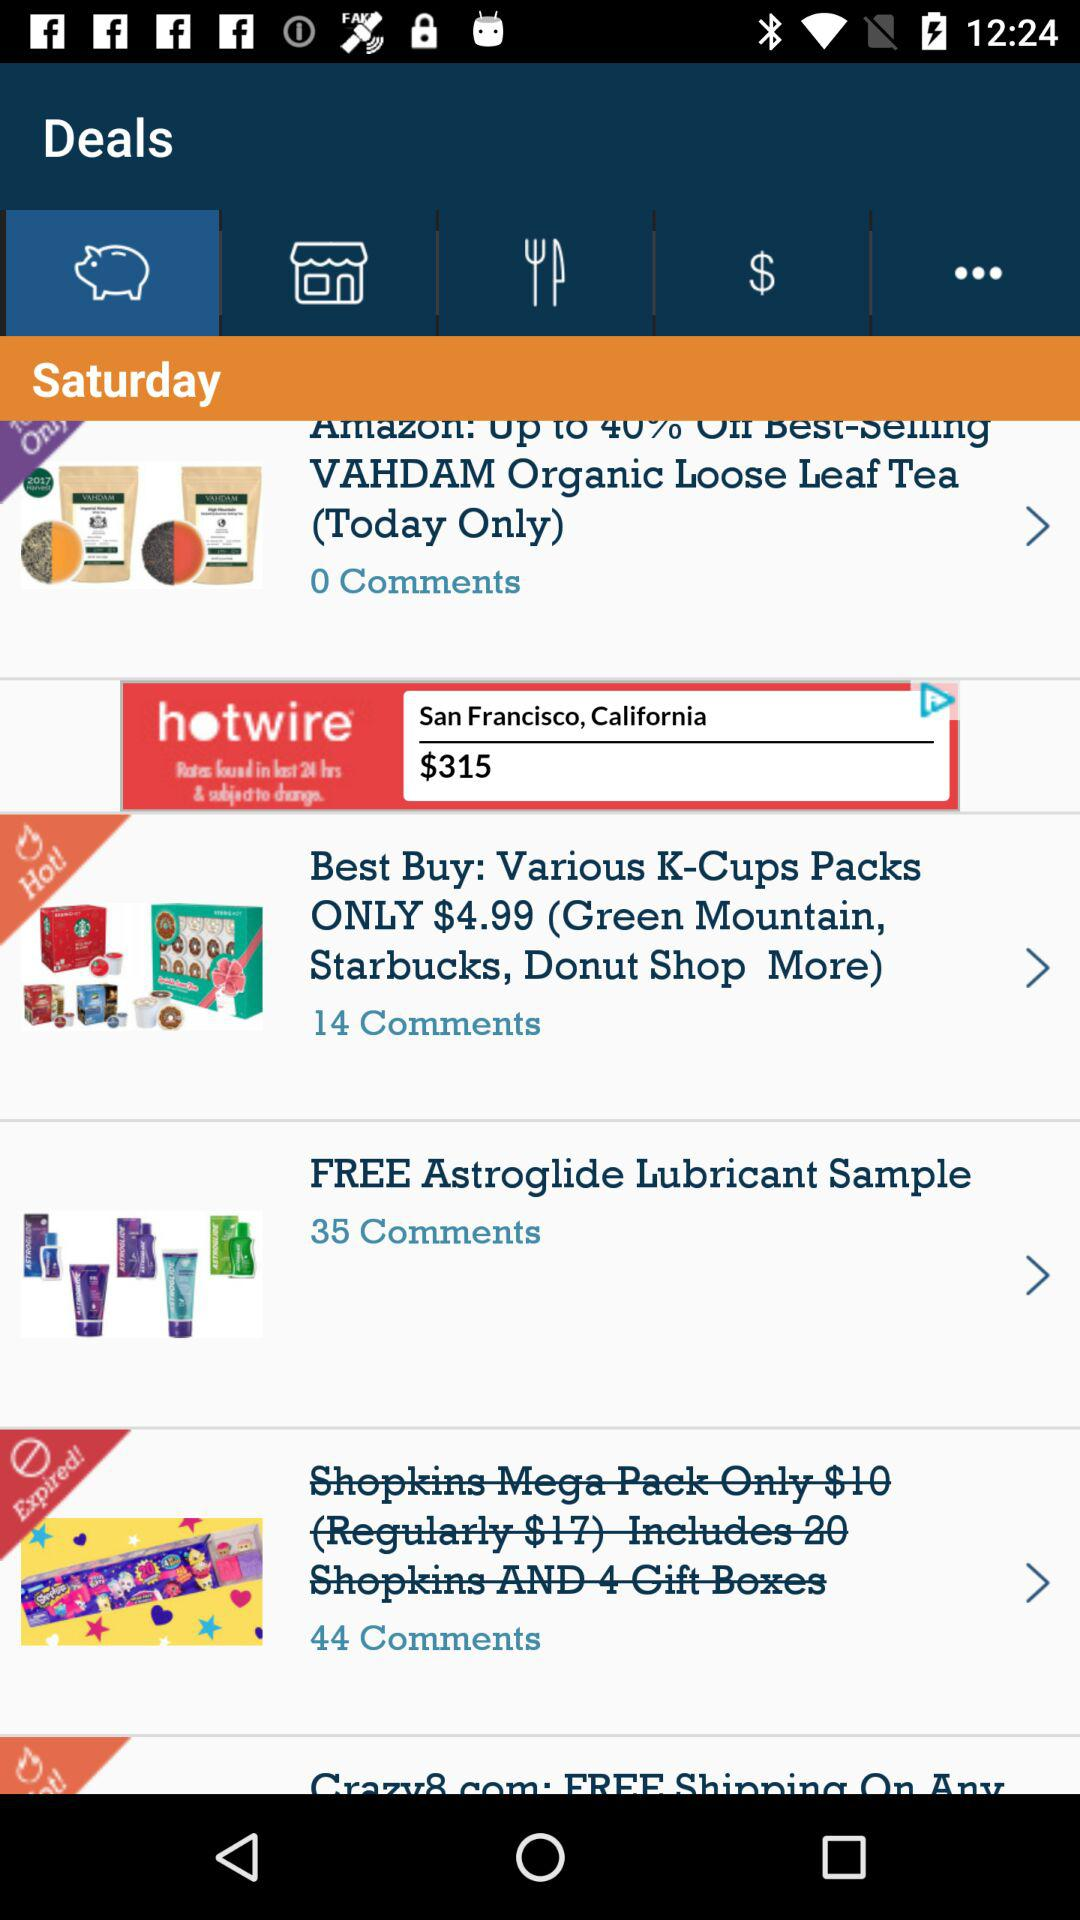What is the price of various K-Cups packs? The price is $4.99. 